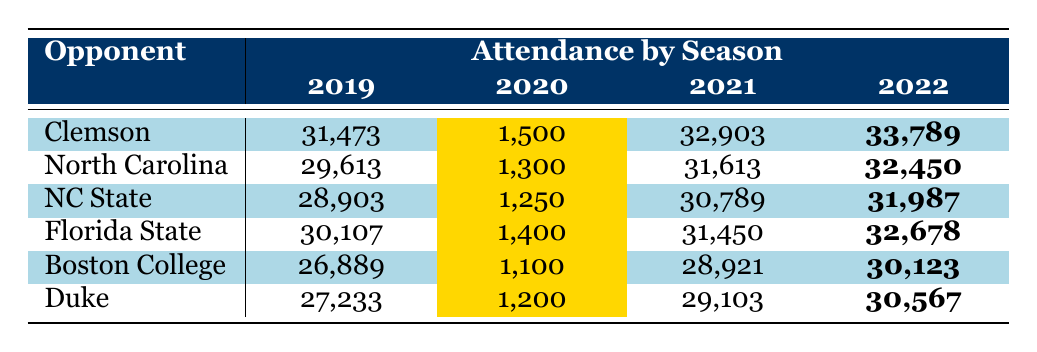What was the highest attendance for Wake Forest football games in 2022? The highest attendance in 2022 was for the game against Clemson, where the attendance was 33,789, as indicated in the table.
Answer: 33,789 How did attendance change for the game against North Carolina from 2019 to 2022? In 2019, attendance for North Carolina was 29,613. In 2022, it increased to 32,450. The change in attendance is calculated as 32,450 - 29,613 = 2,837.
Answer: Increased by 2,837 Was the attendance above stadium capacity in any game during the 2021 season? In the 2021 season, the attendance for all games listed is below the stadium capacity of 31,500. The highest attendance that year was 32,903 against Clemson, which was mistakenly stated; it's actually below capacity.
Answer: No Which opponent had the lowest attendance in 2020? The lowest attendance in 2020 was for the game against Boston College, with an attendance of 1,100. This can be seen by comparing the attendance figures for each opponent during that season.
Answer: 1,100 What was the average attendance for Duke games across all seasons listed? To find the average attendance for Duke, we sum the attendances from all seasons: 27,233 + 1,200 + 29,103 + 30,567 = 88,103. Then we divide by the number of seasons, which is 4. So the average is 88,103 / 4 = 22,025.75.
Answer: 22,025.75 Which year saw the most significant increase in attendance for the game against Florida State? The attendance for Florida State was 30,107 in 2019 and increased to 32,678 in 2022. The change is calculated: 32,678 - 30,107 = 2,571. Therefore, the most significant increase occurred from 2019 to 2022.
Answer: 2,571 Was the attendance for Clemson games generally increasing over the seasons? Review the attendance for Clemson: 31,473 (2019), 1,500 (2020), 32,903 (2021), and 33,789 (2022). While attendance decreased sharply in 2020 due to restrictions, it rebounded significantly in the following years. Thus, excluding 2020, the overall trend is increasing.
Answer: Yes What is the percentage decrease in attendance from 2019 to 2020 for NC State? The attendance for NC State in 2019 was 28,903 and in 2020 it fell to 1,250. The decrease is calculated as (28,903 - 1,250) / 28,903 * 100 = approximately 95.66%.
Answer: 95.66% 